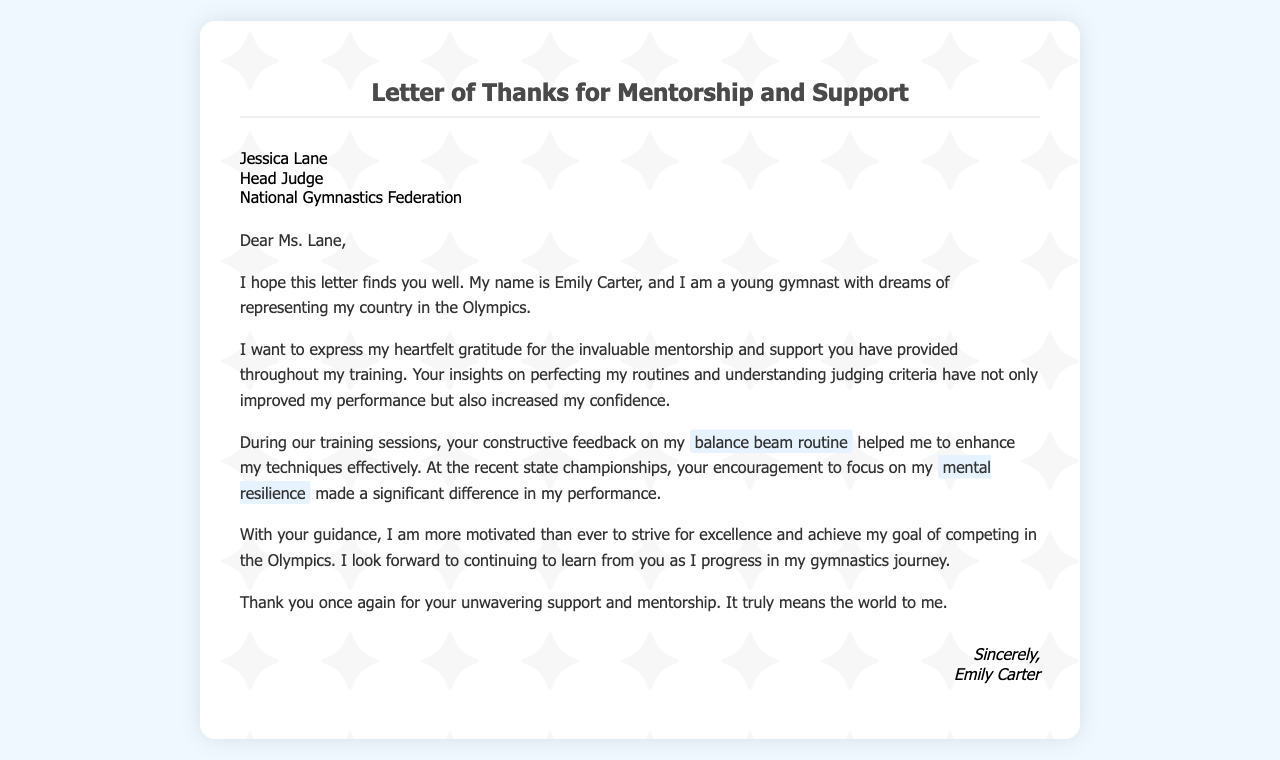what is the name of the recipient? The name of the recipient is printed at the beginning of the letter.
Answer: Jessica Lane what is the title of the recipient? The title of the recipient is specified in the document.
Answer: Head Judge who is the author of the letter? The author’s name is stated at the end of the letter.
Answer: Emily Carter what is the main reason for writing this letter? The purpose of the letter is indicated in the opening sentences where gratitude is expressed.
Answer: Gratitude for mentorship and support what specific routine did Emily receive feedback on? The specific routine is mentioned in the section discussing training sessions.
Answer: balance beam routine what aspect of performance did the mentor encourage Emily to focus on? This aspect is highlighted during the mention of state championships.
Answer: mental resilience what is Emily's ultimate dream according to the letter? Emily's goal is clearly articulated in the introduction of the letter.
Answer: Competing in the Olympics how did Emily feel about the mentorship received? The feelings expressed in the letter indicate the emotional impact of the mentorship.
Answer: Grateful what is the closing salutation of the letter? The closing salutation is stated at the end of the letter before the signature.
Answer: Sincerely 